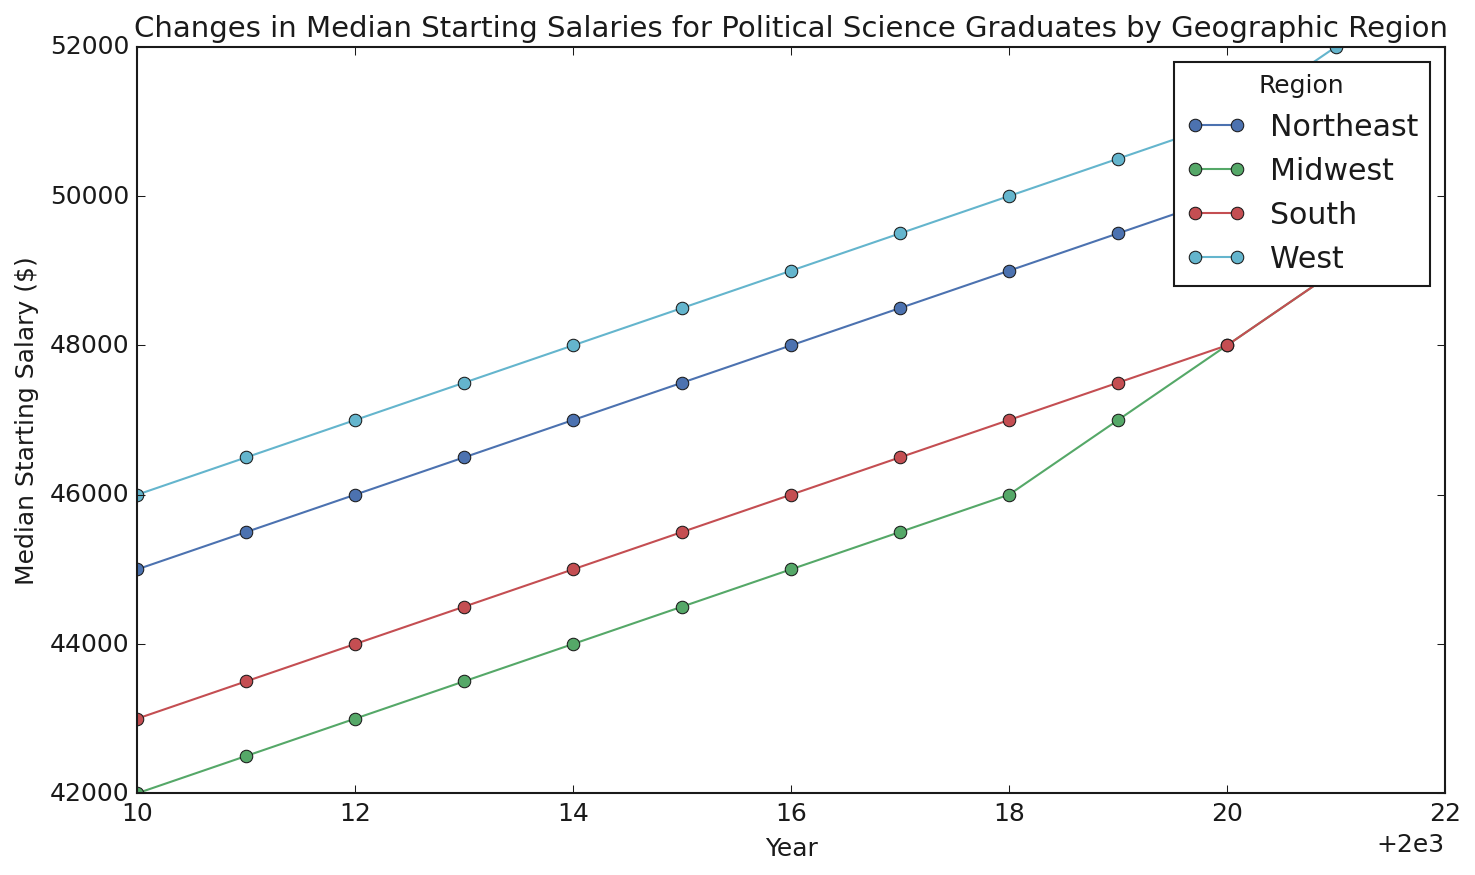Which region had the highest median starting salary for Political Science graduates in 2021? By looking at the line chart for the year 2021, the highest point represents the West region.
Answer: West Which region shows the most consistent increase in median starting salaries from 2010 to 2021? All regions show an increase, but the rate appears most consistent (i.e., similar increments year over year) in the South region.
Answer: South What is the difference in median starting salary between the Northeast and Midwest regions in 2020? The median salary for Northeast in 2020 is $50,000, and for Midwest, it is $48,000. The difference is $50,000 - $48,000 = $2,000.
Answer: $2,000 In which year did the South region surpass the Midwest region in median starting salaries? By tracing the lines for South and Midwest, the South region surpasses the Midwest in 2012.
Answer: 2012 Calculate the average median starting salary for the West region from 2010 to 2021. Sum the median salaries for the West from 2010 to 2021 and divide by the number of years: (46000 + 46500 + 47000 + 47500 + 48000 + 48500 + 49000 + 49500 + 50000 + 50500 + 51000 + 52000) / 12 = $48,500.
Answer: $48,500 Which region shows the largest increase in median starting salary between 2010 and 2021? Calculate the difference between the salaries for 2010 and 2021 for each region. The largest increase is for the West: $52,000 (2021) - $46,000 (2010) = $6,000.
Answer: West How many regions had a median starting salary of at least $49,000 in 2018? By looking at the 2018 median salaries, the Northeast ($49,000), South ($47,000), and West ($50,000) have at least $49,000. That makes 2 regions.
Answer: 2 What is the median starting salary trend in the Northeast region from 2010 to 2021? The line for the Northeast shows a steady upward trend every year from $45,000 in 2010 to $51,000 in 2021.
Answer: Steady increase 